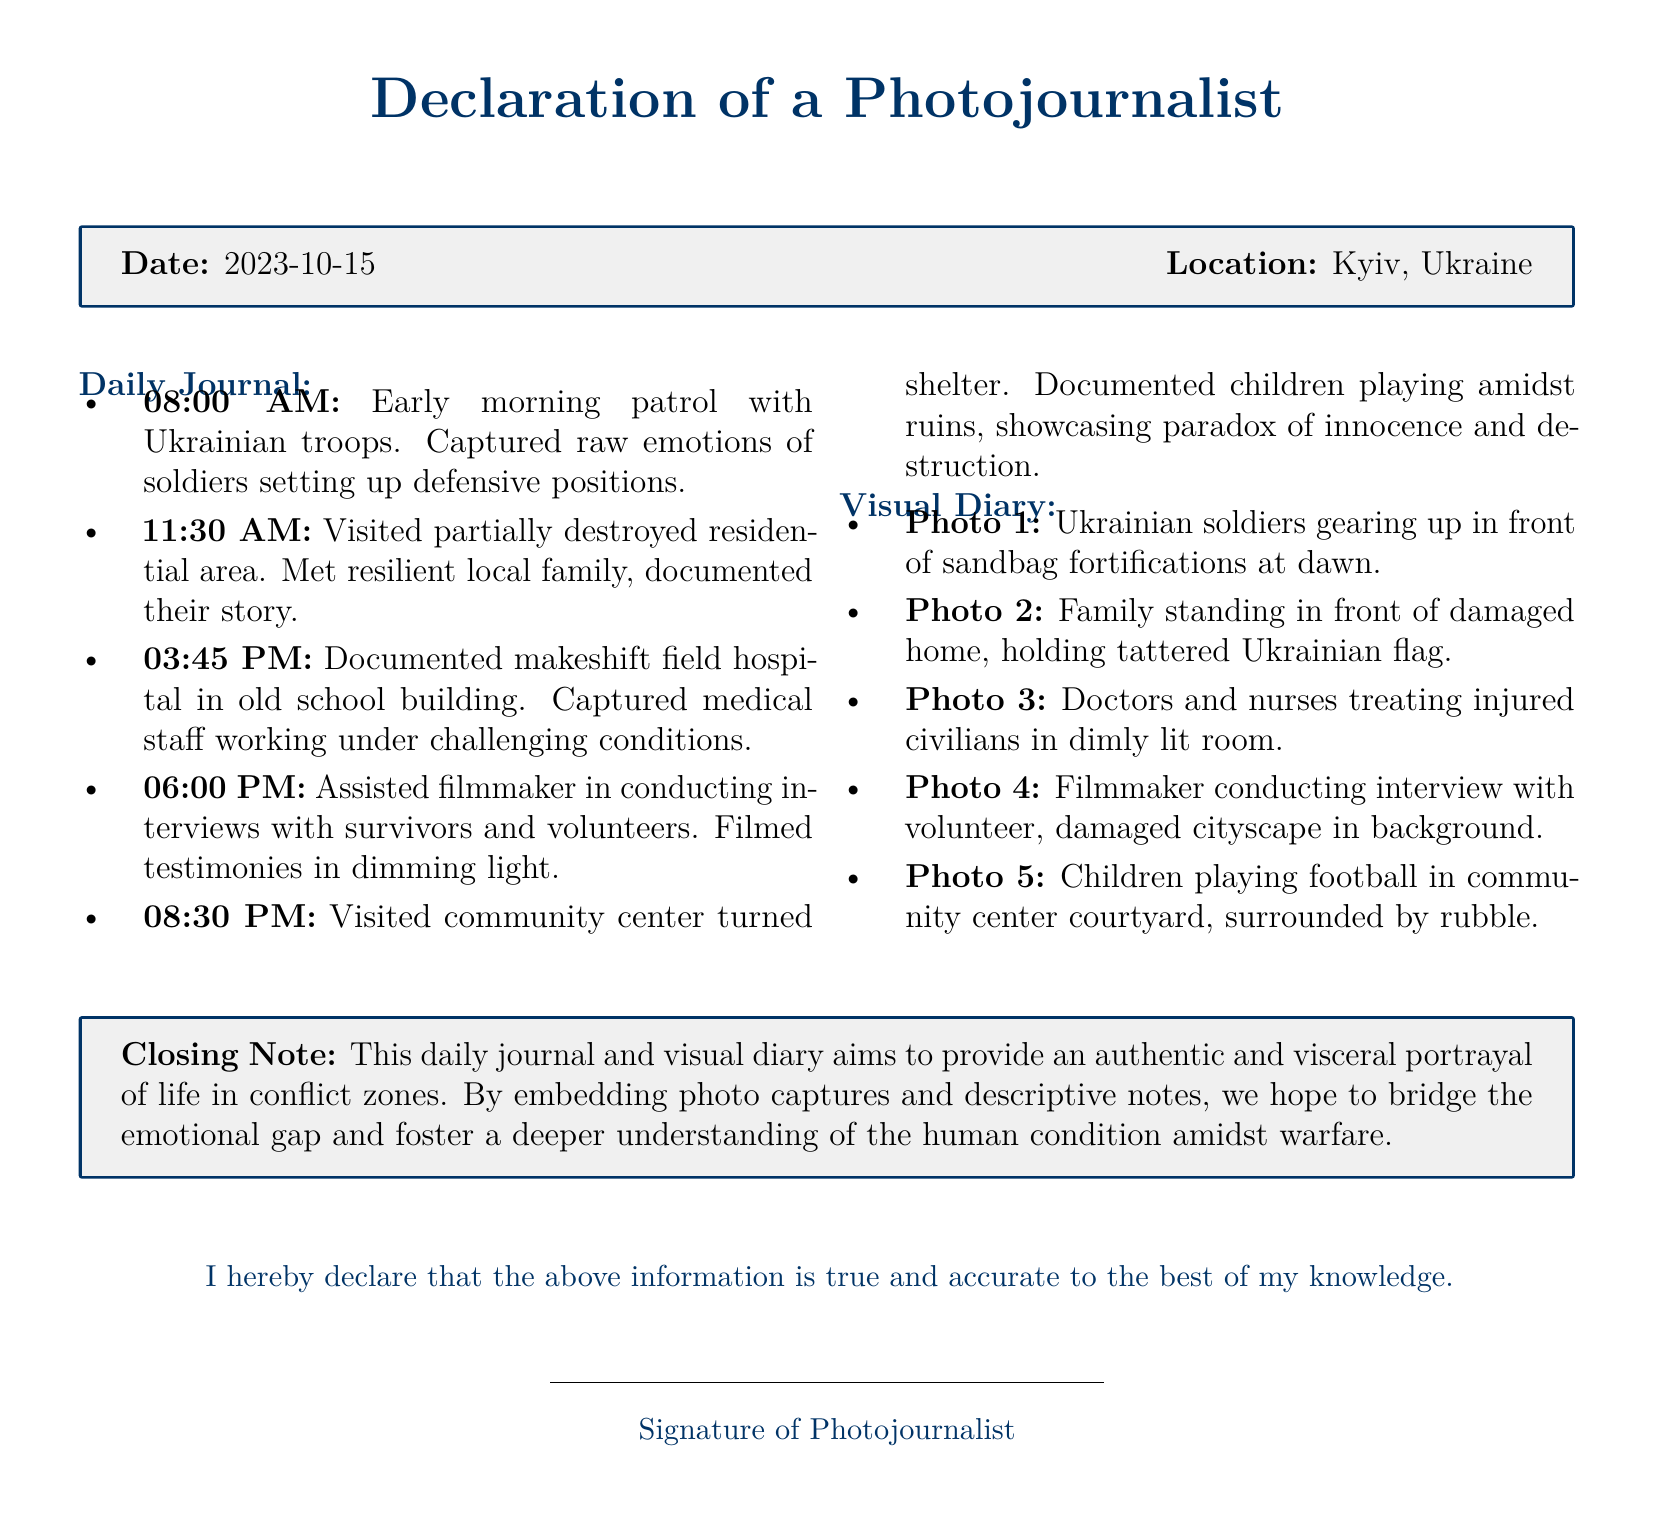What is the date of the declaration? The date of the declaration is stated in the document header.
Answer: 2023-10-15 What is the location of the declaration? The location of the declaration is indicated alongside the date.
Answer: Kyiv, Ukraine What time was the early morning patrol documented? The time of the early morning patrol is noted in the daily journal section.
Answer: 08:00 AM How many photos are included in the visual diary? The total number of photos is listed in the visual diary section.
Answer: 5 What significant event occurred at 11:30 AM? The event documented at that time is specified in the daily journal.
Answer: Visited partially destroyed residential area Which group assisted the filmmaker with interviews? The group that assisted in conducting interviews is mentioned in the daily journal.
Answer: Survivors and volunteers What is the primary aim of the daily journal and visual diary? The aim is expressed in the closing note of the document.
Answer: Provide an authentic and visceral portrayal What does the photo of children depict? The photo described in the visual diary captures a specific activity.
Answer: Children playing football in community center courtyard 